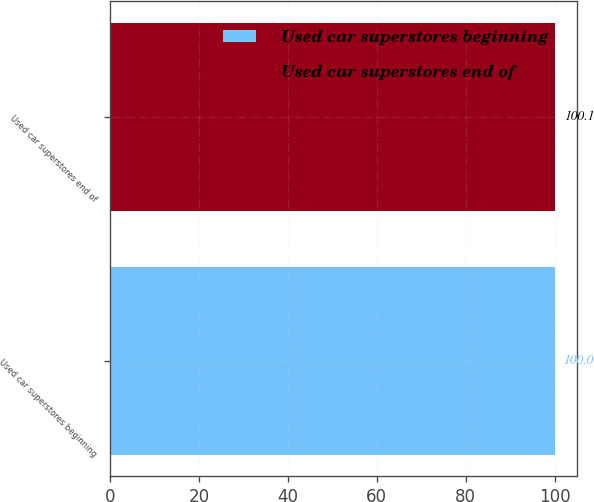Convert chart to OTSL. <chart><loc_0><loc_0><loc_500><loc_500><bar_chart><fcel>Used car superstores beginning<fcel>Used car superstores end of<nl><fcel>100<fcel>100.1<nl></chart> 